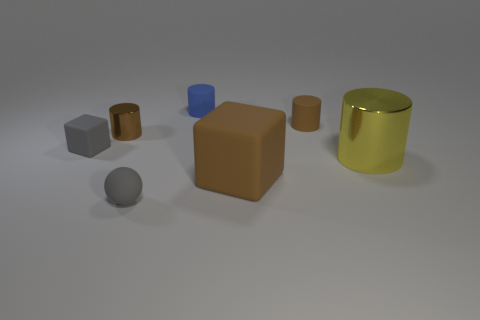How many metallic cylinders are there?
Your answer should be compact. 2. There is a thing that is in front of the tiny brown metallic cylinder and left of the gray sphere; what size is it?
Offer a very short reply. Small. What is the shape of the brown rubber thing that is the same size as the blue matte cylinder?
Make the answer very short. Cylinder. Is there a shiny cylinder that is in front of the small matte block that is on the left side of the big metal thing?
Your answer should be very brief. Yes. What color is the other shiny object that is the same shape as the big yellow metal object?
Give a very brief answer. Brown. There is a cube that is left of the brown rubber block; is its color the same as the ball?
Provide a succinct answer. Yes. How many objects are cubes that are on the left side of the tiny brown shiny object or green shiny balls?
Give a very brief answer. 1. What is the material of the yellow object behind the large object in front of the shiny object that is on the right side of the gray matte sphere?
Give a very brief answer. Metal. Are there more tiny rubber objects that are in front of the gray cube than shiny objects in front of the sphere?
Your response must be concise. Yes. What number of cylinders are big red things or gray things?
Keep it short and to the point. 0. 